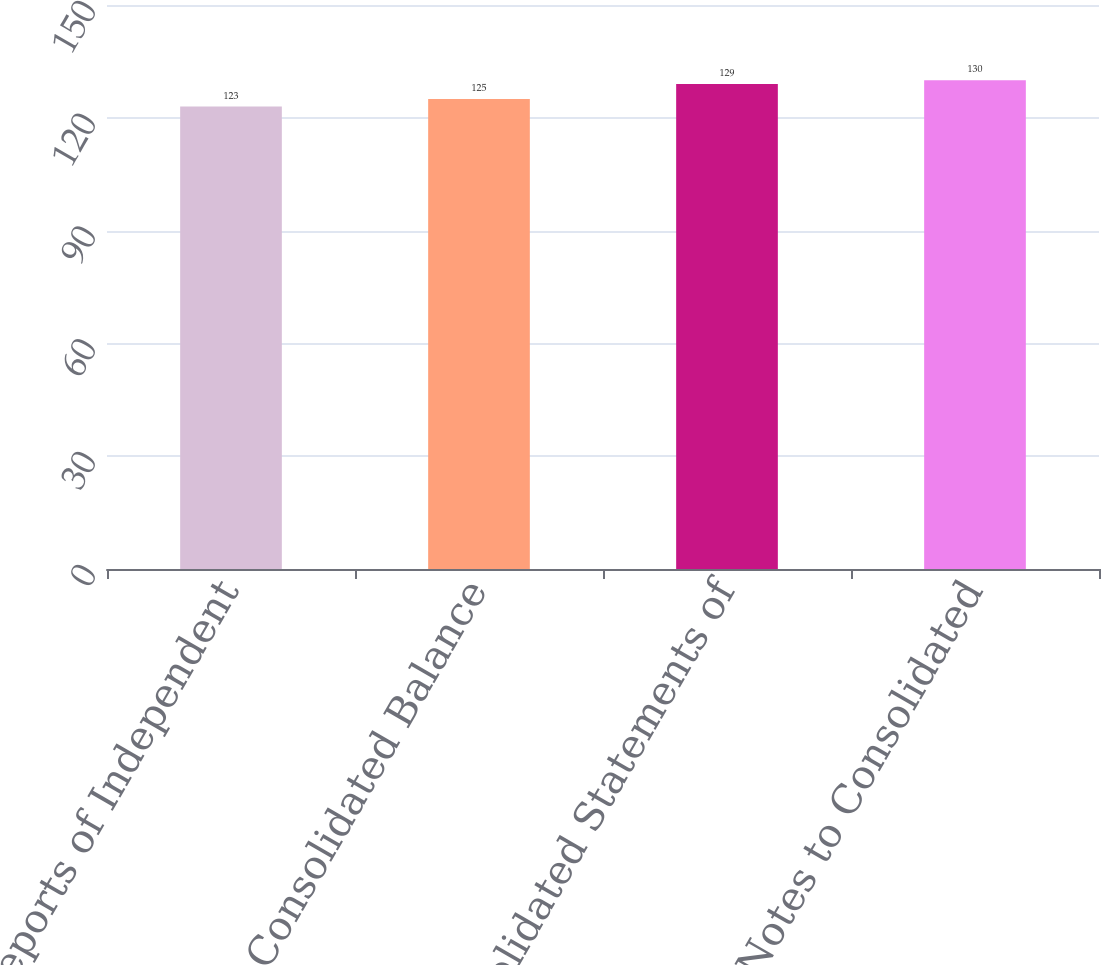Convert chart to OTSL. <chart><loc_0><loc_0><loc_500><loc_500><bar_chart><fcel>Reports of Independent<fcel>Consolidated Balance<fcel>Consolidated Statements of<fcel>Notes to Consolidated<nl><fcel>123<fcel>125<fcel>129<fcel>130<nl></chart> 